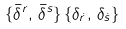<formula> <loc_0><loc_0><loc_500><loc_500>\{ \bar { \delta } ^ { r } , \, \bar { \delta } ^ { s } \} \, \{ \delta _ { \dot { r } } , \, \delta _ { \dot { s } } \}</formula> 